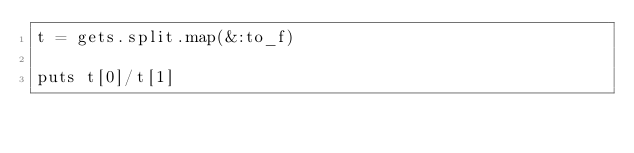Convert code to text. <code><loc_0><loc_0><loc_500><loc_500><_Ruby_>t = gets.split.map(&:to_f)

puts t[0]/t[1]</code> 